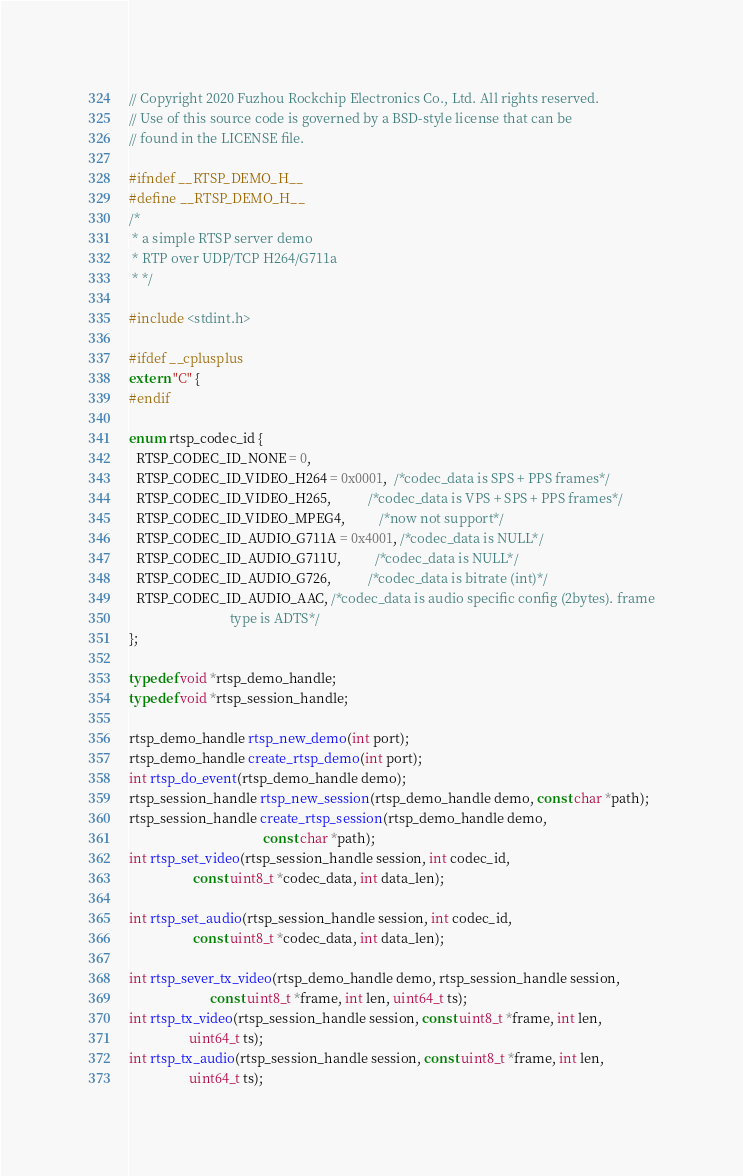<code> <loc_0><loc_0><loc_500><loc_500><_C_>// Copyright 2020 Fuzhou Rockchip Electronics Co., Ltd. All rights reserved.
// Use of this source code is governed by a BSD-style license that can be
// found in the LICENSE file.

#ifndef __RTSP_DEMO_H__
#define __RTSP_DEMO_H__
/*
 * a simple RTSP server demo
 * RTP over UDP/TCP H264/G711a
 * */

#include <stdint.h>

#ifdef __cplusplus
extern "C" {
#endif

enum rtsp_codec_id {
  RTSP_CODEC_ID_NONE = 0,
  RTSP_CODEC_ID_VIDEO_H264 = 0x0001,  /*codec_data is SPS + PPS frames*/
  RTSP_CODEC_ID_VIDEO_H265,           /*codec_data is VPS + SPS + PPS frames*/
  RTSP_CODEC_ID_VIDEO_MPEG4,          /*now not support*/
  RTSP_CODEC_ID_AUDIO_G711A = 0x4001, /*codec_data is NULL*/
  RTSP_CODEC_ID_AUDIO_G711U,          /*codec_data is NULL*/
  RTSP_CODEC_ID_AUDIO_G726,           /*codec_data is bitrate (int)*/
  RTSP_CODEC_ID_AUDIO_AAC, /*codec_data is audio specific config (2bytes). frame
                              type is ADTS*/
};

typedef void *rtsp_demo_handle;
typedef void *rtsp_session_handle;

rtsp_demo_handle rtsp_new_demo(int port);
rtsp_demo_handle create_rtsp_demo(int port);
int rtsp_do_event(rtsp_demo_handle demo);
rtsp_session_handle rtsp_new_session(rtsp_demo_handle demo, const char *path);
rtsp_session_handle create_rtsp_session(rtsp_demo_handle demo,
                                        const char *path);
int rtsp_set_video(rtsp_session_handle session, int codec_id,
                   const uint8_t *codec_data, int data_len);

int rtsp_set_audio(rtsp_session_handle session, int codec_id,
                   const uint8_t *codec_data, int data_len);

int rtsp_sever_tx_video(rtsp_demo_handle demo, rtsp_session_handle session,
                        const uint8_t *frame, int len, uint64_t ts);
int rtsp_tx_video(rtsp_session_handle session, const uint8_t *frame, int len,
                  uint64_t ts);
int rtsp_tx_audio(rtsp_session_handle session, const uint8_t *frame, int len,
                  uint64_t ts);</code> 